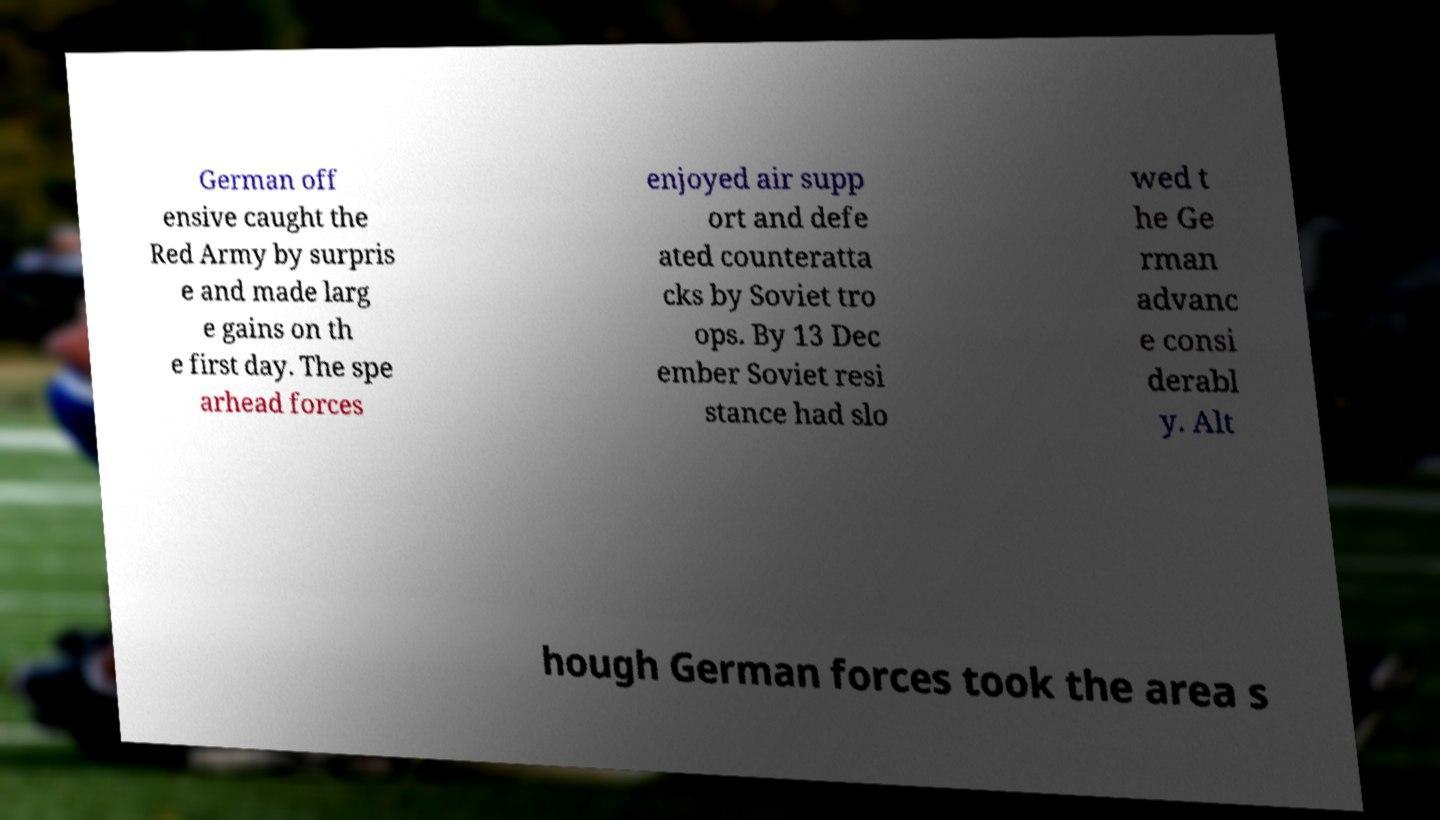For documentation purposes, I need the text within this image transcribed. Could you provide that? German off ensive caught the Red Army by surpris e and made larg e gains on th e first day. The spe arhead forces enjoyed air supp ort and defe ated counteratta cks by Soviet tro ops. By 13 Dec ember Soviet resi stance had slo wed t he Ge rman advanc e consi derabl y. Alt hough German forces took the area s 